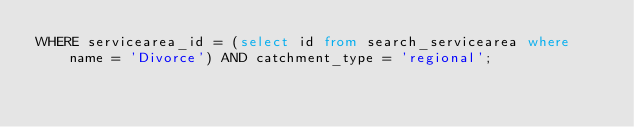Convert code to text. <code><loc_0><loc_0><loc_500><loc_500><_SQL_>WHERE servicearea_id = (select id from search_servicearea where name = 'Divorce') AND catchment_type = 'regional';
</code> 